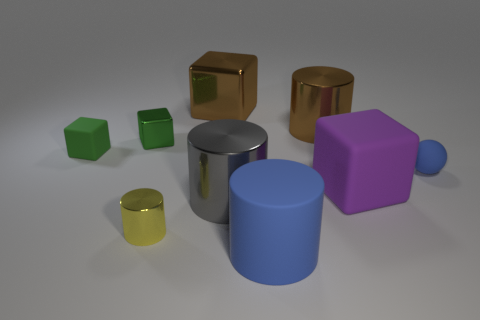Subtract all green matte blocks. How many blocks are left? 3 Subtract 4 cylinders. How many cylinders are left? 0 Add 1 big yellow cylinders. How many objects exist? 10 Add 7 large blue matte things. How many large blue matte things are left? 8 Add 9 gray shiny things. How many gray shiny things exist? 10 Subtract all gray cylinders. How many cylinders are left? 3 Subtract 0 cyan spheres. How many objects are left? 9 Subtract all spheres. How many objects are left? 8 Subtract all green spheres. Subtract all cyan cylinders. How many spheres are left? 1 Subtract all green blocks. How many purple cylinders are left? 0 